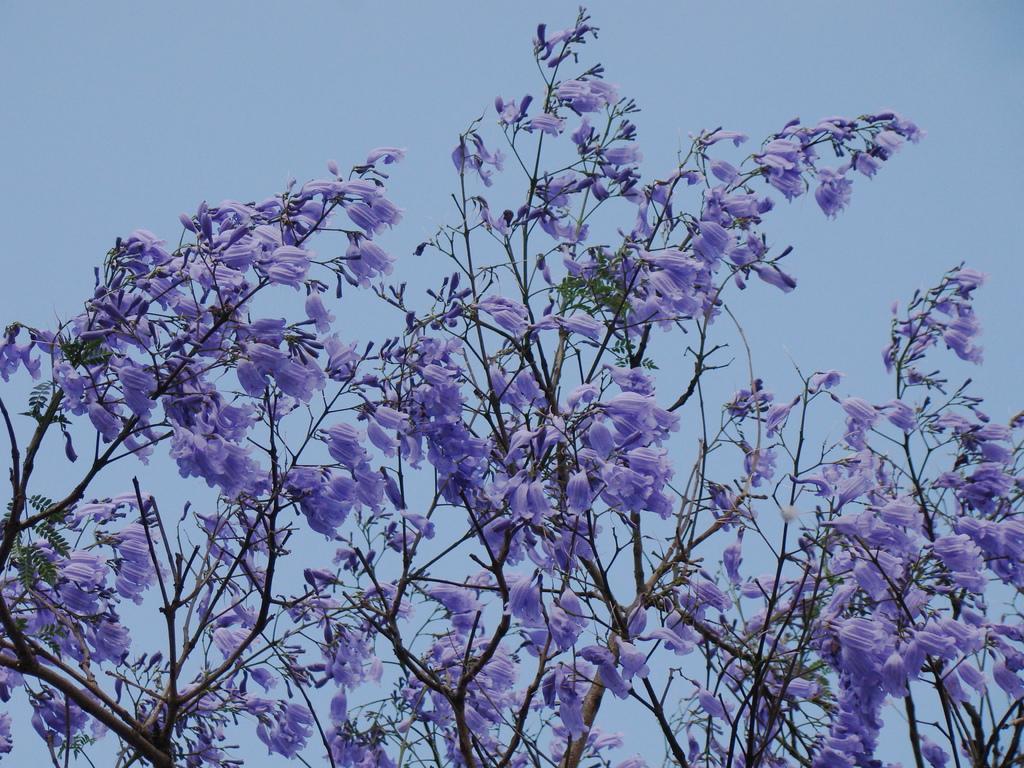Could you give a brief overview of what you see in this image? In this picture we can see purple color flowers and leaves on the tree. On the top there is a sky. 